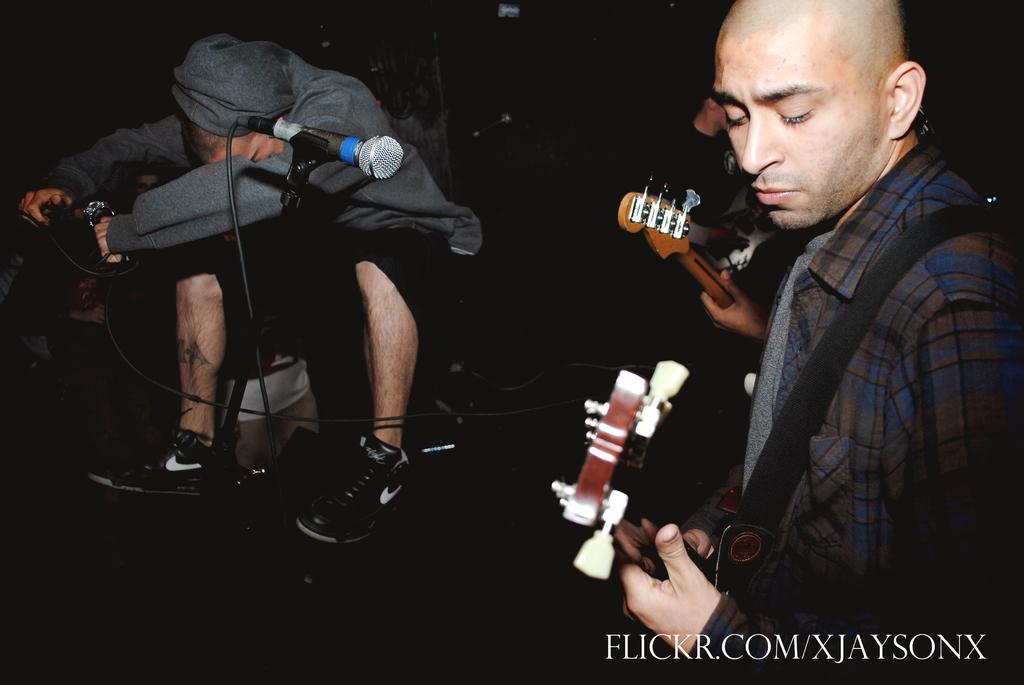In one or two sentences, can you explain what this image depicts? The background of the picture is completely dark. Here we can see one man sitting. This is a mike. We can see two persons standing and playing guitars. 